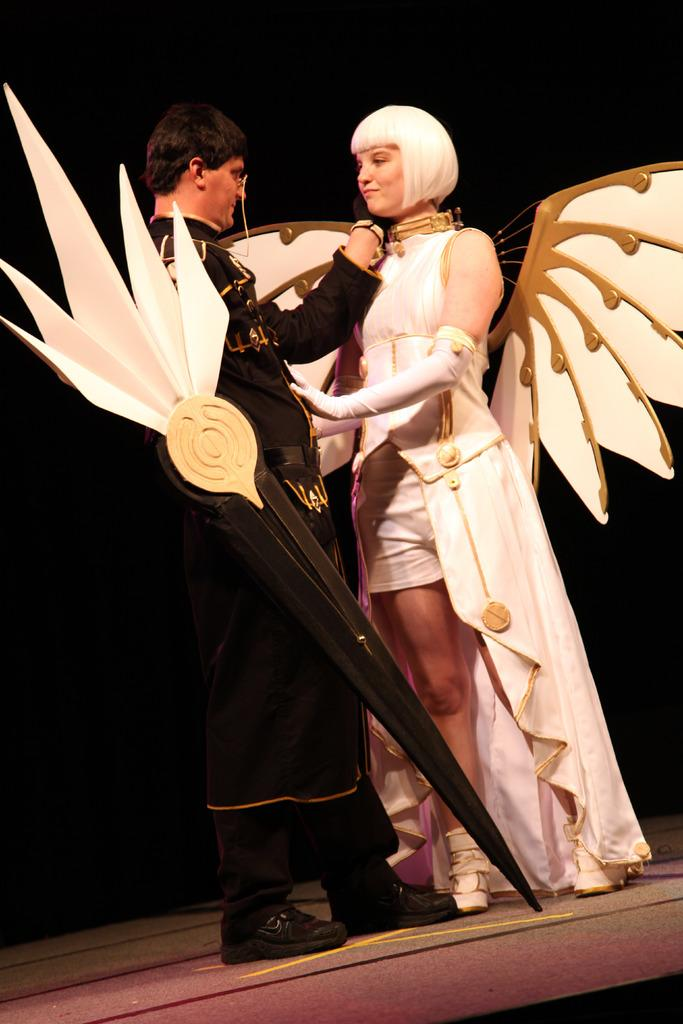How many people are in the image? There are persons in the image, but the exact number is not specified. What are the persons wearing? The persons are wearing clothes. What can be seen in the middle of the image? There is an object in the middle of the image. What type of uncle can be seen in the image? There is no uncle present in the image. How does the sun appear in the image? The facts do not mention the presence of the sun in the image. 